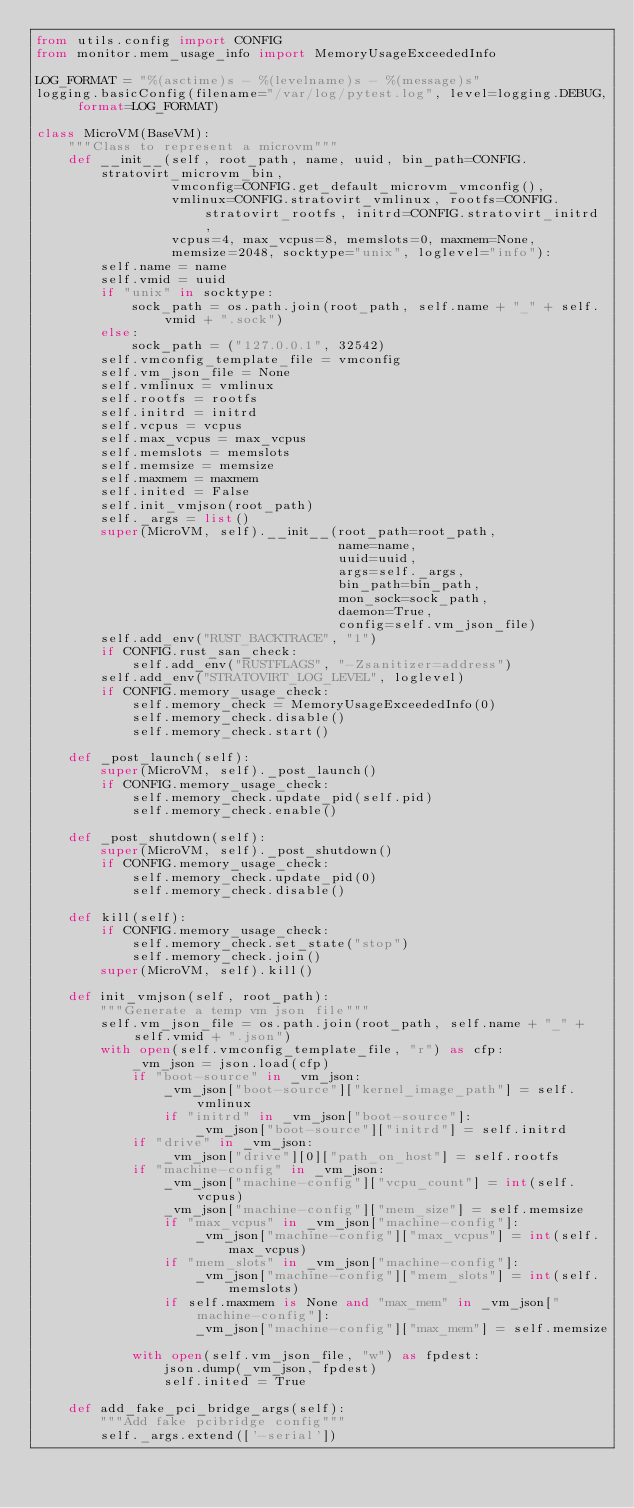Convert code to text. <code><loc_0><loc_0><loc_500><loc_500><_Python_>from utils.config import CONFIG
from monitor.mem_usage_info import MemoryUsageExceededInfo

LOG_FORMAT = "%(asctime)s - %(levelname)s - %(message)s"
logging.basicConfig(filename="/var/log/pytest.log", level=logging.DEBUG, format=LOG_FORMAT)

class MicroVM(BaseVM):
    """Class to represent a microvm"""
    def __init__(self, root_path, name, uuid, bin_path=CONFIG.stratovirt_microvm_bin,
                 vmconfig=CONFIG.get_default_microvm_vmconfig(),
                 vmlinux=CONFIG.stratovirt_vmlinux, rootfs=CONFIG.stratovirt_rootfs, initrd=CONFIG.stratovirt_initrd,
                 vcpus=4, max_vcpus=8, memslots=0, maxmem=None,
                 memsize=2048, socktype="unix", loglevel="info"):
        self.name = name
        self.vmid = uuid
        if "unix" in socktype:
            sock_path = os.path.join(root_path, self.name + "_" + self.vmid + ".sock")
        else:
            sock_path = ("127.0.0.1", 32542)
        self.vmconfig_template_file = vmconfig
        self.vm_json_file = None
        self.vmlinux = vmlinux
        self.rootfs = rootfs
        self.initrd = initrd
        self.vcpus = vcpus
        self.max_vcpus = max_vcpus
        self.memslots = memslots
        self.memsize = memsize
        self.maxmem = maxmem
        self.inited = False
        self.init_vmjson(root_path)
        self._args = list()
        super(MicroVM, self).__init__(root_path=root_path,
                                      name=name,
                                      uuid=uuid,
                                      args=self._args,
                                      bin_path=bin_path,
                                      mon_sock=sock_path,
                                      daemon=True,
                                      config=self.vm_json_file)
        self.add_env("RUST_BACKTRACE", "1")
        if CONFIG.rust_san_check:
            self.add_env("RUSTFLAGS", "-Zsanitizer=address")
        self.add_env("STRATOVIRT_LOG_LEVEL", loglevel)
        if CONFIG.memory_usage_check:
            self.memory_check = MemoryUsageExceededInfo(0)
            self.memory_check.disable()
            self.memory_check.start()

    def _post_launch(self):
        super(MicroVM, self)._post_launch()
        if CONFIG.memory_usage_check:
            self.memory_check.update_pid(self.pid)
            self.memory_check.enable()

    def _post_shutdown(self):
        super(MicroVM, self)._post_shutdown()
        if CONFIG.memory_usage_check:
            self.memory_check.update_pid(0)
            self.memory_check.disable()

    def kill(self):
        if CONFIG.memory_usage_check:
            self.memory_check.set_state("stop")
            self.memory_check.join()
        super(MicroVM, self).kill()

    def init_vmjson(self, root_path):
        """Generate a temp vm json file"""
        self.vm_json_file = os.path.join(root_path, self.name + "_" + self.vmid + ".json")
        with open(self.vmconfig_template_file, "r") as cfp:
            _vm_json = json.load(cfp)
            if "boot-source" in _vm_json:
                _vm_json["boot-source"]["kernel_image_path"] = self.vmlinux
                if "initrd" in _vm_json["boot-source"]:
                    _vm_json["boot-source"]["initrd"] = self.initrd
            if "drive" in _vm_json:
                _vm_json["drive"][0]["path_on_host"] = self.rootfs
            if "machine-config" in _vm_json:
                _vm_json["machine-config"]["vcpu_count"] = int(self.vcpus)
                _vm_json["machine-config"]["mem_size"] = self.memsize
                if "max_vcpus" in _vm_json["machine-config"]:
                    _vm_json["machine-config"]["max_vcpus"] = int(self.max_vcpus)
                if "mem_slots" in _vm_json["machine-config"]:
                    _vm_json["machine-config"]["mem_slots"] = int(self.memslots)
                if self.maxmem is None and "max_mem" in _vm_json["machine-config"]:
                    _vm_json["machine-config"]["max_mem"] = self.memsize

            with open(self.vm_json_file, "w") as fpdest:
                json.dump(_vm_json, fpdest)
                self.inited = True

    def add_fake_pci_bridge_args(self):
        """Add fake pcibridge config"""
        self._args.extend(['-serial'])
</code> 